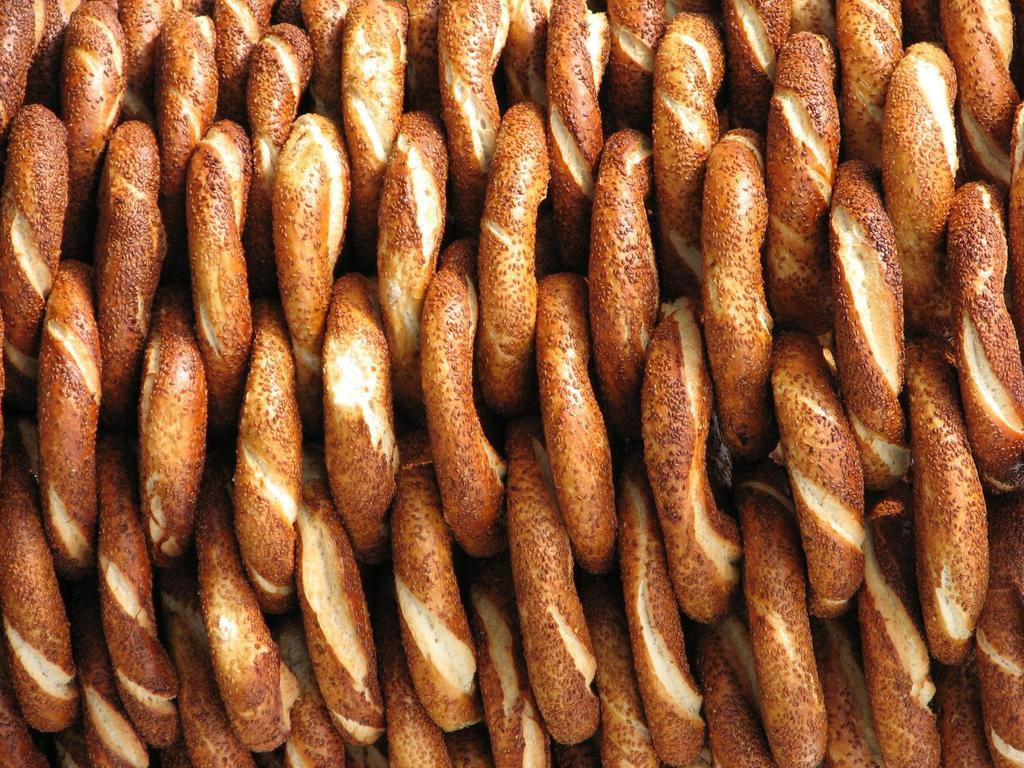What types of objects can be seen in the image? There are food items in the image. Can you describe the colors of the food items? The food items are in brown and cream colors. What type of tank is visible in the image? There is no tank present in the image; it features food items in brown and cream colors. How many thumbs can be seen interacting with the food items in the image? There is no thumb visible in the image, as it focuses on the food items themselves. 